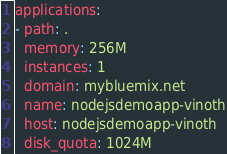<code> <loc_0><loc_0><loc_500><loc_500><_YAML_>applications:
- path: .
  memory: 256M
  instances: 1
  domain: mybluemix.net
  name: nodejsdemoapp-vinoth
  host: nodejsdemoapp-vinoth
  disk_quota: 1024M
</code> 